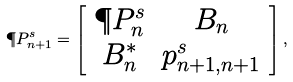<formula> <loc_0><loc_0><loc_500><loc_500>\P P ^ { s } _ { n + 1 } = \left [ \begin{array} { c c } \P P ^ { s } _ { n } & B _ { n } \\ B _ { n } ^ { * } & p ^ { s } _ { n + 1 , n + 1 } \end{array} \right ] ,</formula> 